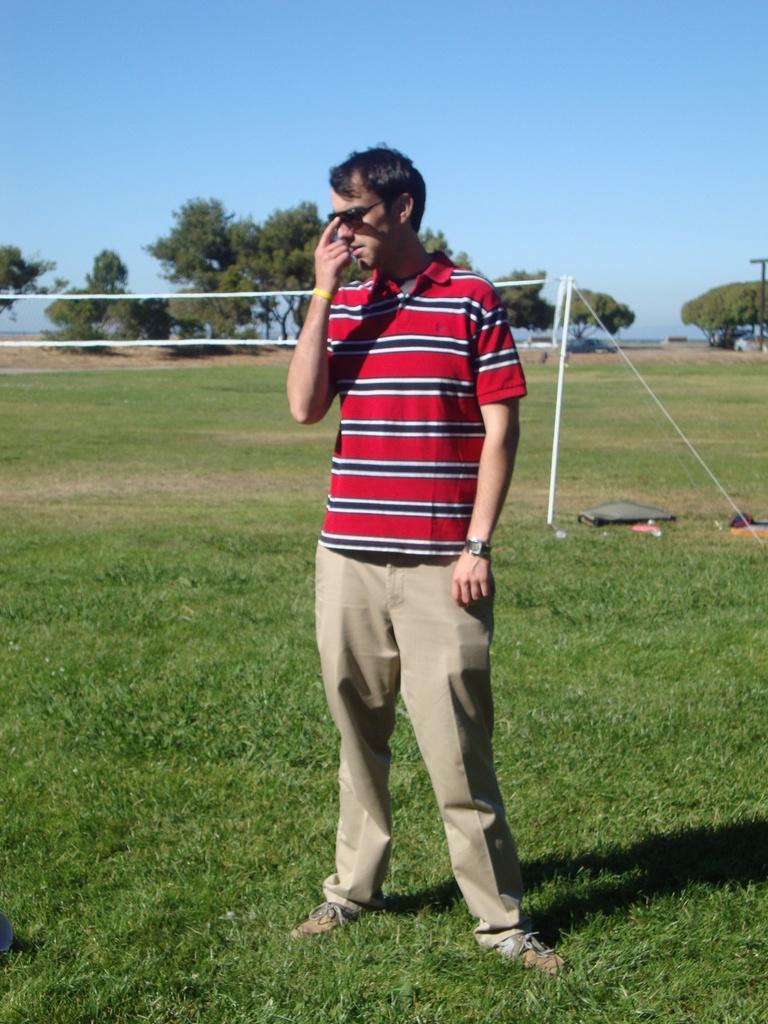How would you summarize this image in a sentence or two? In this image we can see a person standing and wearing goggles on the ground, also we can see a net, there are some trees, grass and other objects on the ground, in the background, we can see the sky. 